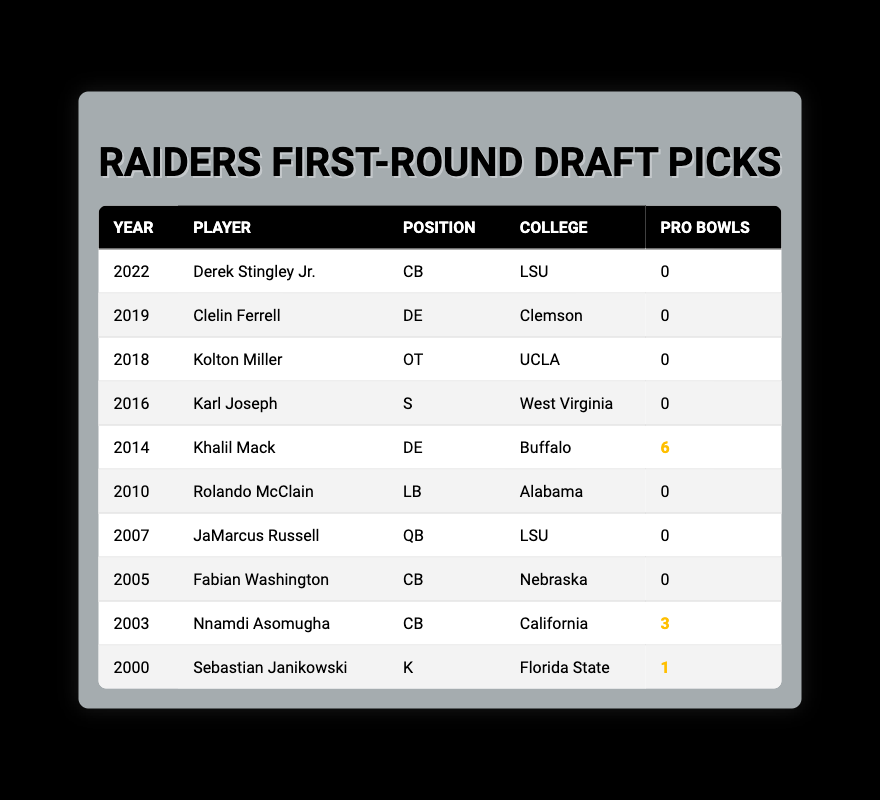What position did Khalil Mack play? The table lists Khalil Mack as a defensive end (DE) and shows the year he was drafted, his college, and the number of Pro Bowls.
Answer: DE How many Pro Bowls did Nnamdi Asomugha make? According to the table, Nnamdi Asomugha is listed with 3 Pro Bowls, which can be directly retrieved.
Answer: 3 Which player was drafted in 2010? The table shows that Rolando McClain was the player drafted in 2010; it contains his college and position as well.
Answer: Rolando McClain What is the total number of Pro Bowls for first-round picks from 2000 to 2022? To find the total, we add the Pro Bowls for each player: 0 + 0 + 0 + 0 + 6 + 0 + 0 + 0 + 3 + 1 = 10. The total Pro Bowls for the Raiders' first-round picks is 10.
Answer: 10 Did the Raiders draft a quarterback in the first round prior to 2018? Looking at the table, JaMarcus Russell is the only quarterback drafted, and he was drafted in 2007. Thus, the Raiders did draft a QB before 2018.
Answer: Yes Which college had the most first-round picks in the table? By analyzing the table, LSU had two players (Derek Stingley Jr. in 2022 and JaMarcus Russell in 2007), while other colleges like Alabama, California, and UCLA had one. No college had more than two.
Answer: LSU Was there a first-round draft pick with 0 Pro Bowls? Scanning through the table, several players have 0 Pro Bowls, such as Derek Stingley Jr., Clelin Ferrell, Kolton Miller, and more. Hence, yes, there are picks with 0 Pro Bowls.
Answer: Yes What year had the highest number of Pro Bowls among first-round draft picks? Khalil Mack, drafted in 2014, has the highest number of Pro Bowls with 6. Therefore, the year 2014 had the highest total of Pro Bowls among the given players.
Answer: 2014 How many players listed played the cornerback position? The table indicates three players in the cornerback position: Derek Stingley Jr., Fabian Washington, and Nnamdi Asomugha. Adding these gives a total of three cornerbacks from the table.
Answer: 3 Was Khalil Mack the only first-round draft pick to achieve more than one Pro Bowl? Khalil Mack is indeed the only player listed with 6 Pro Bowls, making him the only pick to achieve more than one Pro Bowl from 2000 to 2022.
Answer: Yes 